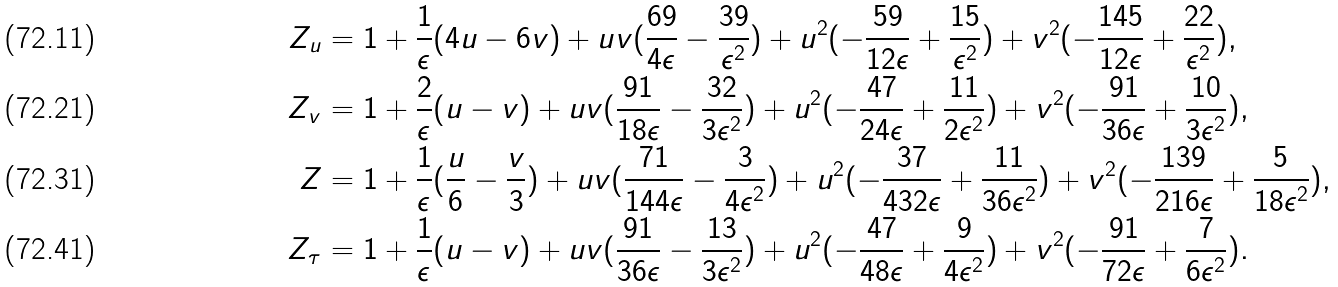<formula> <loc_0><loc_0><loc_500><loc_500>Z _ { u } & = 1 + \frac { 1 } { \epsilon } ( 4 u - 6 v ) + u v ( \frac { 6 9 } { 4 \epsilon } - \frac { 3 9 } { \epsilon ^ { 2 } } ) + u ^ { 2 } ( - \frac { 5 9 } { 1 2 \epsilon } + \frac { 1 5 } { \epsilon ^ { 2 } } ) + v ^ { 2 } ( - \frac { 1 4 5 } { 1 2 \epsilon } + \frac { 2 2 } { \epsilon ^ { 2 } } ) , \\ Z _ { v } & = 1 + \frac { 2 } { \epsilon } ( u - v ) + u v ( \frac { 9 1 } { 1 8 \epsilon } - \frac { 3 2 } { 3 \epsilon ^ { 2 } } ) + u ^ { 2 } ( - \frac { 4 7 } { 2 4 \epsilon } + \frac { 1 1 } { 2 \epsilon ^ { 2 } } ) + v ^ { 2 } ( - \frac { 9 1 } { 3 6 \epsilon } + \frac { 1 0 } { 3 \epsilon ^ { 2 } } ) , \\ Z & = 1 + \frac { 1 } { \epsilon } ( \frac { u } { 6 } - \frac { v } { 3 } ) + u v ( \frac { 7 1 } { 1 4 4 \epsilon } - \frac { 3 } { 4 \epsilon ^ { 2 } } ) + u ^ { 2 } ( - \frac { 3 7 } { 4 3 2 \epsilon } + \frac { 1 1 } { 3 6 \epsilon ^ { 2 } } ) + v ^ { 2 } ( - \frac { 1 3 9 } { 2 1 6 \epsilon } + \frac { 5 } { 1 8 \epsilon ^ { 2 } } ) , \\ Z _ { \tau } & = 1 + \frac { 1 } { \epsilon } ( u - v ) + u v ( \frac { 9 1 } { 3 6 \epsilon } - \frac { 1 3 } { 3 \epsilon ^ { 2 } } ) + u ^ { 2 } ( - \frac { 4 7 } { 4 8 \epsilon } + \frac { 9 } { 4 \epsilon ^ { 2 } } ) + v ^ { 2 } ( - \frac { 9 1 } { 7 2 \epsilon } + \frac { 7 } { 6 \epsilon ^ { 2 } } ) .</formula> 